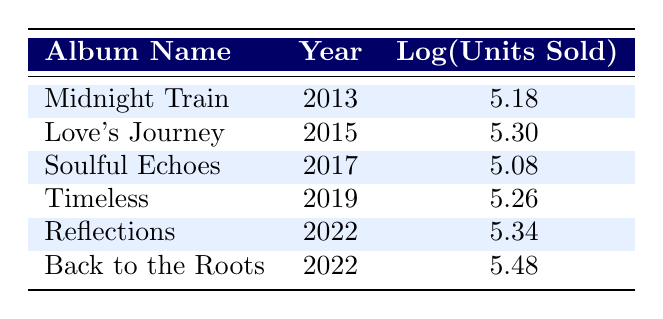What is the album released in the year 2019? Referring to the table, the album listed under the year 2019 is "Timeless".
Answer: Timeless Which album has the highest logarithmic value for units sold? The table indicates that "Back to the Roots" has the highest logarithmic value of 5.48.
Answer: Back to the Roots What are the total units sold for all albums released by Tom Brock from 2013 to 2022? Adding the units sold for each album: 150000 + 200000 + 120000 + 180000 + 220000 + 300000 = 1170000.
Answer: 1170000 Is "Soulful Echoes" the lowest selling album based on logarithmic values? The logarithmic value for "Soulful Echoes" is 5.08, which is lower than that of "Midnight Train" (5.18) and "Timeless" (5.26), but higher than both "Reflections" (5.34) and "Back to the Roots" (5.48), so it is not the lowest.
Answer: No What is the average logarithmic value of units sold for the albums released in 2022? The two albums released in 2022 are "Reflections" and "Back to the Roots", with logarithmic values of 5.34 and 5.48 respectively. To find the average: (5.34 + 5.48) / 2 = 5.41.
Answer: 5.41 